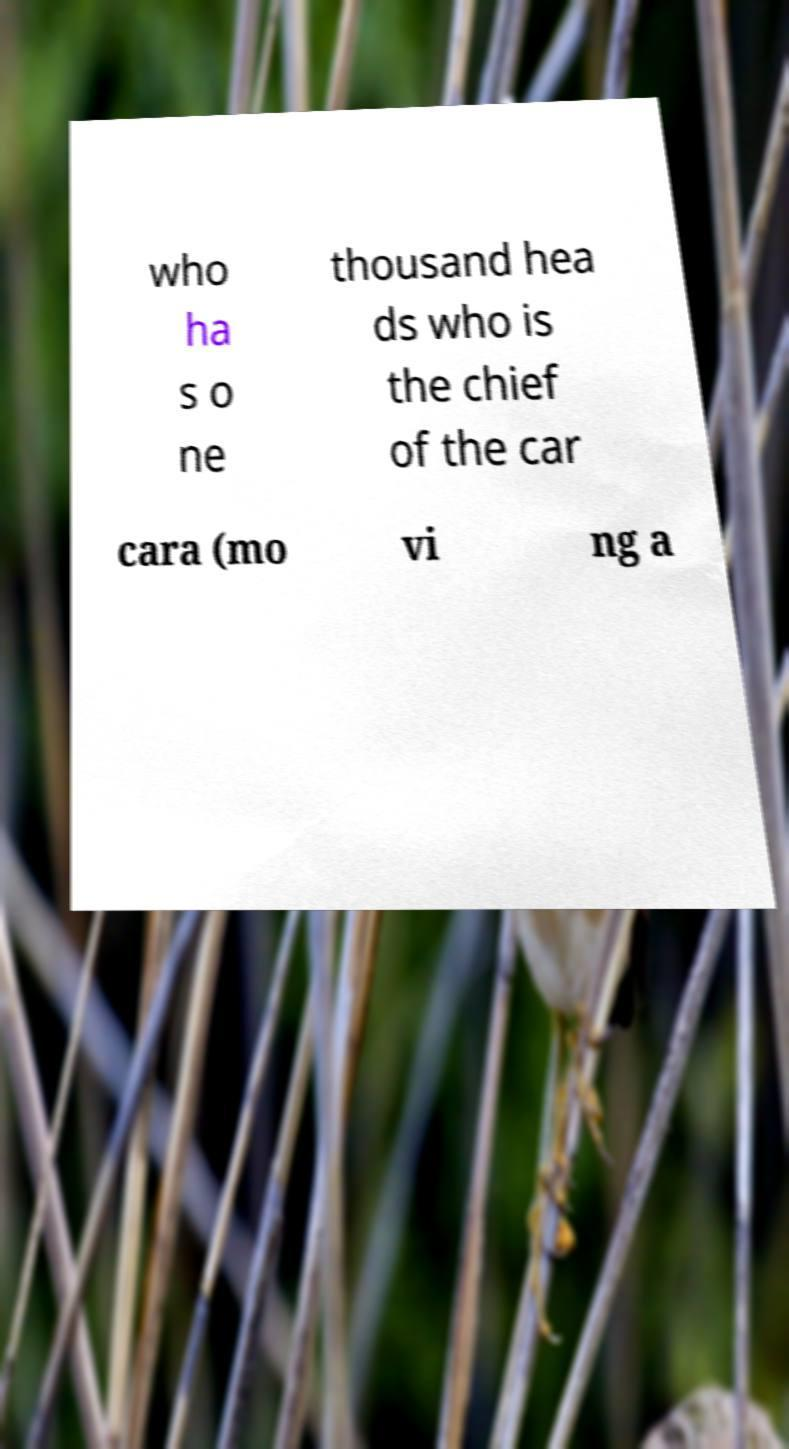I need the written content from this picture converted into text. Can you do that? who ha s o ne thousand hea ds who is the chief of the car cara (mo vi ng a 